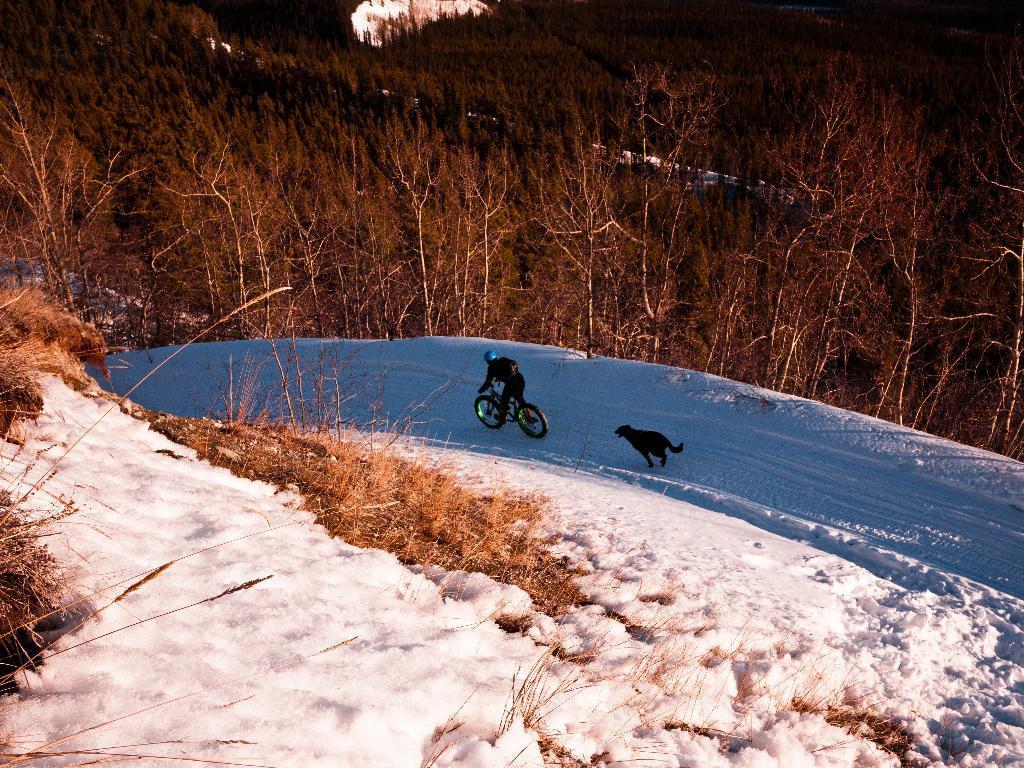Could you give a brief overview of what you see in this image? In this picture we can observe a person cycling a bicycle. There is a black color dog running in this path. We can observe some snow and dried grass here. In the background there are some dried trees. 